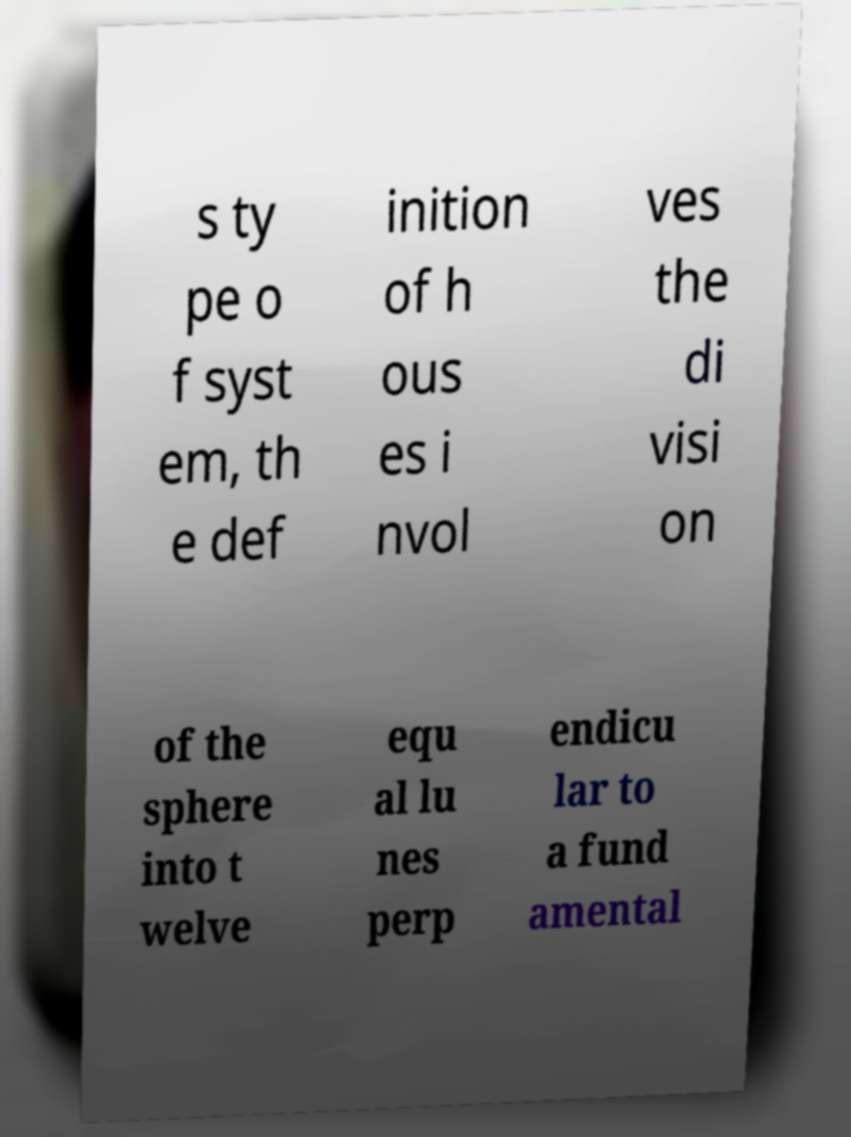What messages or text are displayed in this image? I need them in a readable, typed format. s ty pe o f syst em, th e def inition of h ous es i nvol ves the di visi on of the sphere into t welve equ al lu nes perp endicu lar to a fund amental 